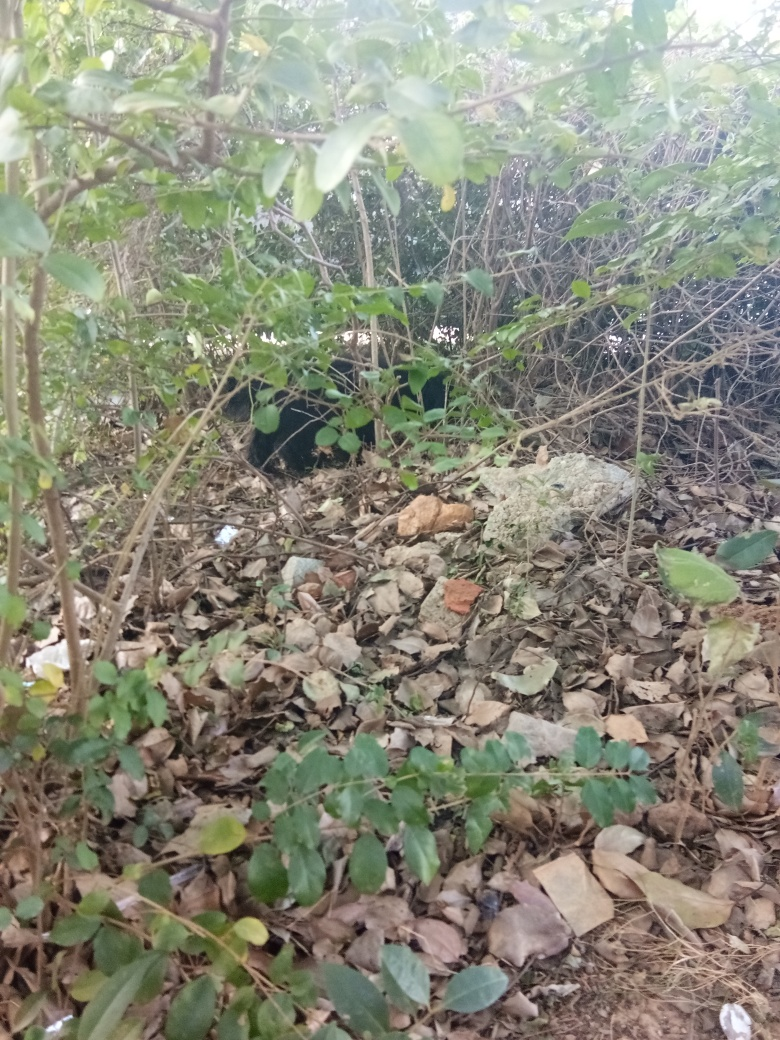Is the quality of this photo good?
A. Average.
B. Unknown.
C. Yes.
D. No. The quality of the photo is average. While it is clear enough to identify the leaves, branches, and some scattered debris or rocks, the image lacks sharpness and the lighting isn't optimal. The composition could be more purposeful in order to create a more engaging and visually appealing photograph. 